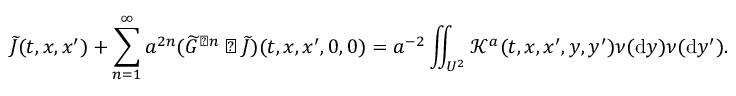Convert formula to latex. <formula><loc_0><loc_0><loc_500><loc_500>\widetilde { J } ( t , x , x ^ { \prime } ) + \sum _ { n = 1 } ^ { \infty } a ^ { 2 n } ( \widetilde { G } ^ { \triangleright n } \triangleright \widetilde { J } ) ( t , x , x ^ { \prime } , 0 , 0 ) = a ^ { - 2 } \iint _ { U ^ { 2 } } \mathcal { K } ^ { a } ( t , x , x ^ { \prime } , y , y ^ { \prime } ) \nu ( { d } y ) \nu ( { d } y ^ { \prime } ) .</formula> 